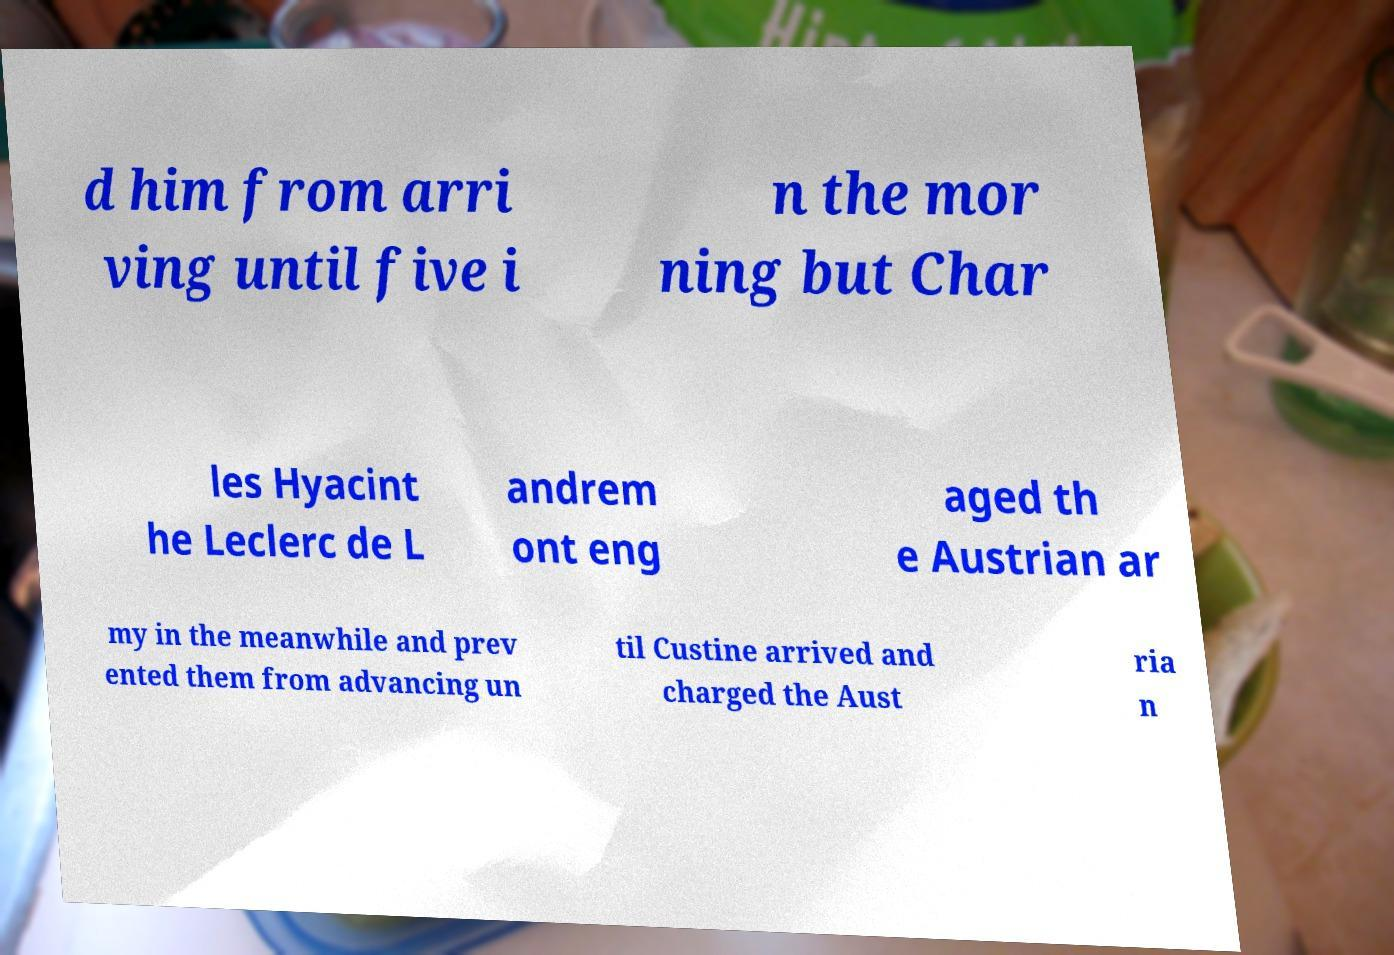There's text embedded in this image that I need extracted. Can you transcribe it verbatim? d him from arri ving until five i n the mor ning but Char les Hyacint he Leclerc de L andrem ont eng aged th e Austrian ar my in the meanwhile and prev ented them from advancing un til Custine arrived and charged the Aust ria n 